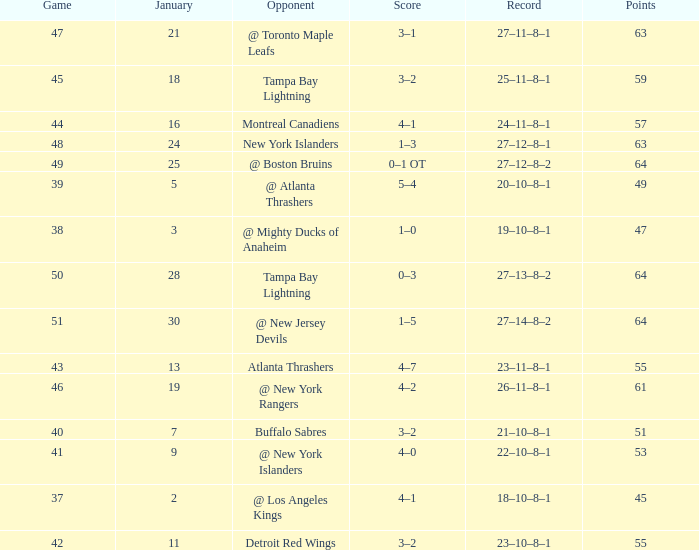How many Points have a January of 18? 1.0. 